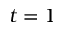Convert formula to latex. <formula><loc_0><loc_0><loc_500><loc_500>t = 1</formula> 